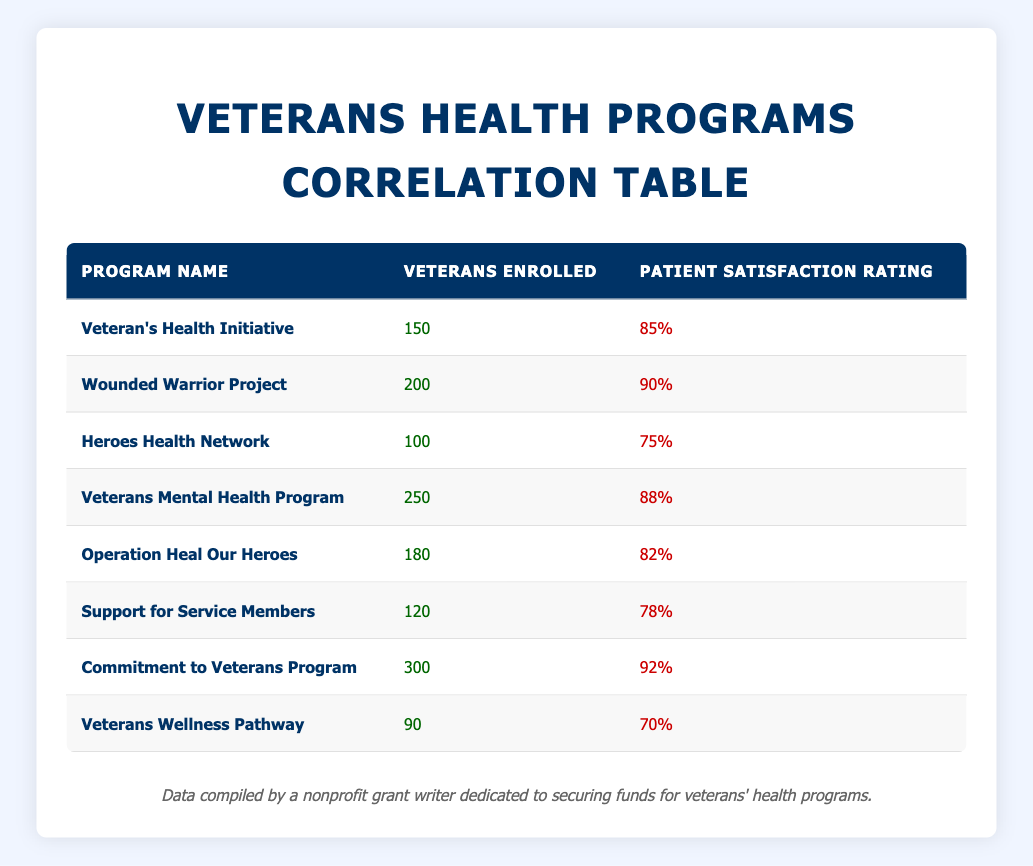What is the maximum patient satisfaction rating among the programs? The table lists the patient satisfaction ratings for each program, and the maximum value can be found by comparing all ratings. The highest rating is 92% for the Commitment to Veterans Program.
Answer: 92% How many veterans are enrolled in the Veterans Mental Health Program? By looking directly at the table, the number of veterans enrolled in the Veterans Mental Health Program is 250.
Answer: 250 Which program has the lowest patient satisfaction rating? The patient satisfaction ratings can be compared, and the lowest is found for the Veterans Wellness Pathway, with a rating of 70%.
Answer: 70% What is the average number of veterans enrolled across all programs? To find the average, we sum the veterans enrolled: 150 + 200 + 100 + 250 + 180 + 120 + 300 + 90 = 1390. There are 8 programs, so the average is 1390/8 = 173.75.
Answer: 173.75 True or False: The Wounded Warrior Project has more veterans enrolled than the Support for Service Members program. Comparing the enrolled numbers, Wounded Warrior Project has 200, and Support for Service Members has 120, so the statement is true.
Answer: True What is the difference in patient satisfaction ratings between the Veteran's Health Initiative and Commitment to Veterans Program? The ratings are 85% for Veteran's Health Initiative and 92% for Commitment to Veterans Program. The difference is 92 - 85 = 7.
Answer: 7 How many programs have a patient satisfaction rating of 85% or higher? Checking the ratings in the table, the programs with ratings of 85% or higher are: Veteran's Health Initiative (85%), Wounded Warrior Project (90%), Veterans Mental Health Program (88%), Commitment to Veterans Program (92%). This gives us a total of 4 programs.
Answer: 4 Which program has the highest number of veterans enrolled and what is its patient satisfaction rating? The Commitment to Veterans Program has the highest number of veterans enrolled at 300, and its patient satisfaction rating is 92%.
Answer: 300, 92% 